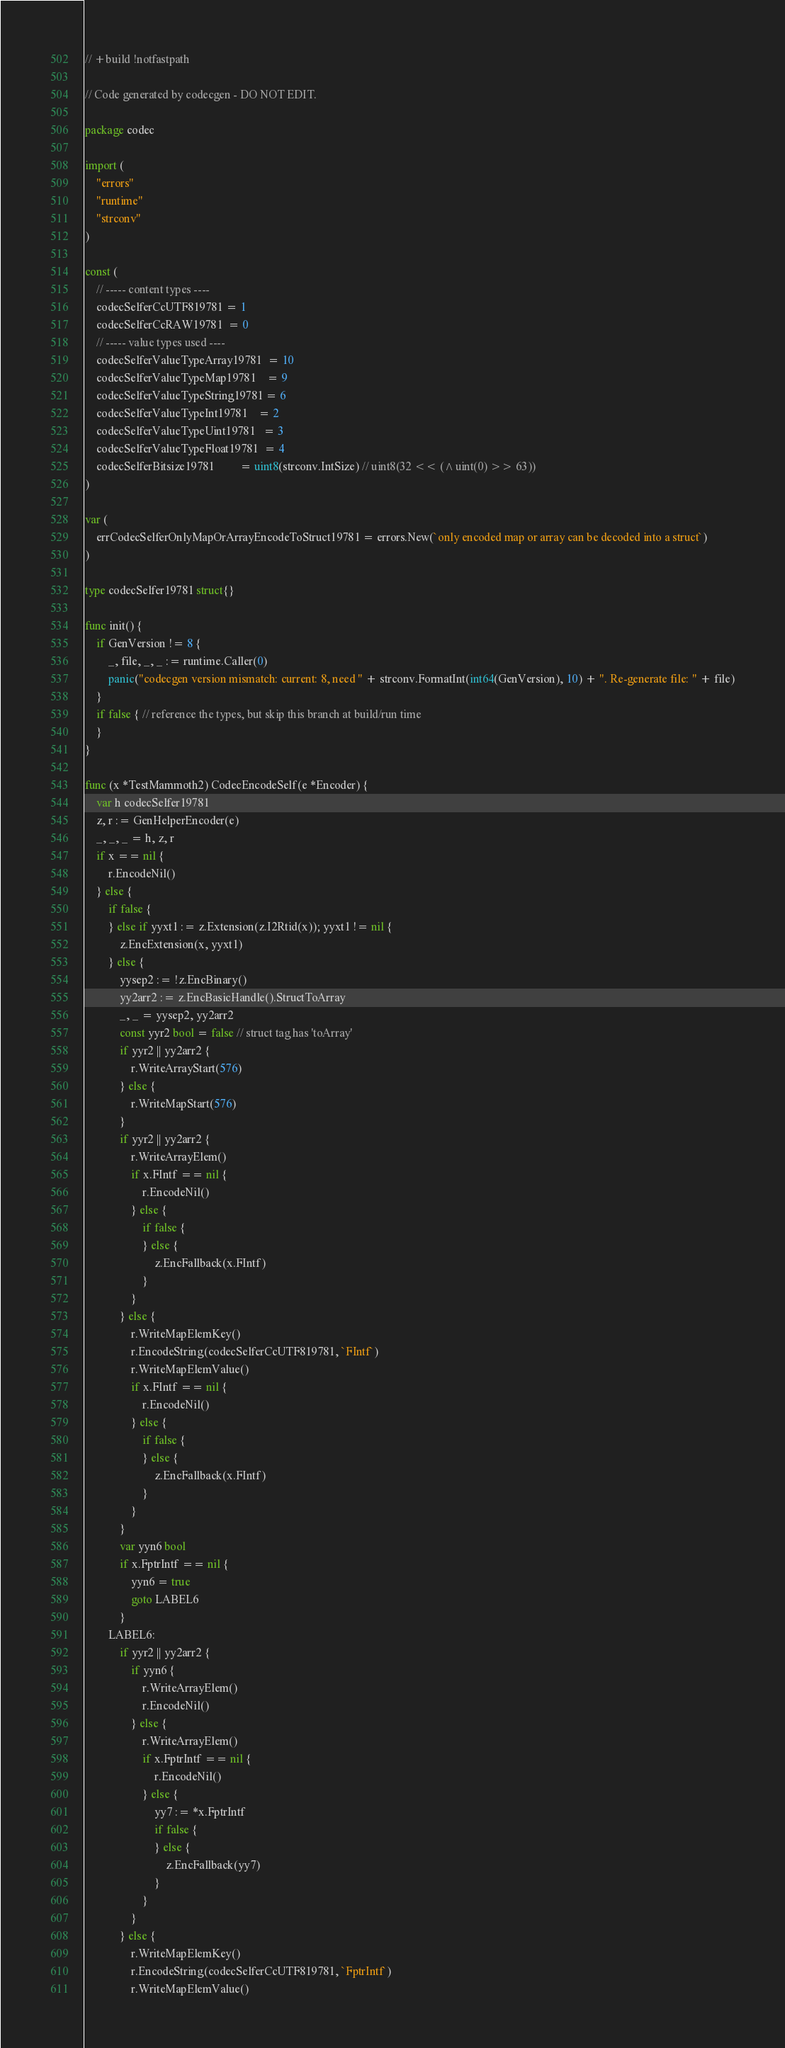Convert code to text. <code><loc_0><loc_0><loc_500><loc_500><_Go_>// +build !notfastpath

// Code generated by codecgen - DO NOT EDIT.

package codec

import (
	"errors"
	"runtime"
	"strconv"
)

const (
	// ----- content types ----
	codecSelferCcUTF819781 = 1
	codecSelferCcRAW19781  = 0
	// ----- value types used ----
	codecSelferValueTypeArray19781  = 10
	codecSelferValueTypeMap19781    = 9
	codecSelferValueTypeString19781 = 6
	codecSelferValueTypeInt19781    = 2
	codecSelferValueTypeUint19781   = 3
	codecSelferValueTypeFloat19781  = 4
	codecSelferBitsize19781         = uint8(strconv.IntSize) // uint8(32 << (^uint(0) >> 63))
)

var (
	errCodecSelferOnlyMapOrArrayEncodeToStruct19781 = errors.New(`only encoded map or array can be decoded into a struct`)
)

type codecSelfer19781 struct{}

func init() {
	if GenVersion != 8 {
		_, file, _, _ := runtime.Caller(0)
		panic("codecgen version mismatch: current: 8, need " + strconv.FormatInt(int64(GenVersion), 10) + ". Re-generate file: " + file)
	}
	if false { // reference the types, but skip this branch at build/run time
	}
}

func (x *TestMammoth2) CodecEncodeSelf(e *Encoder) {
	var h codecSelfer19781
	z, r := GenHelperEncoder(e)
	_, _, _ = h, z, r
	if x == nil {
		r.EncodeNil()
	} else {
		if false {
		} else if yyxt1 := z.Extension(z.I2Rtid(x)); yyxt1 != nil {
			z.EncExtension(x, yyxt1)
		} else {
			yysep2 := !z.EncBinary()
			yy2arr2 := z.EncBasicHandle().StructToArray
			_, _ = yysep2, yy2arr2
			const yyr2 bool = false // struct tag has 'toArray'
			if yyr2 || yy2arr2 {
				r.WriteArrayStart(576)
			} else {
				r.WriteMapStart(576)
			}
			if yyr2 || yy2arr2 {
				r.WriteArrayElem()
				if x.FIntf == nil {
					r.EncodeNil()
				} else {
					if false {
					} else {
						z.EncFallback(x.FIntf)
					}
				}
			} else {
				r.WriteMapElemKey()
				r.EncodeString(codecSelferCcUTF819781, `FIntf`)
				r.WriteMapElemValue()
				if x.FIntf == nil {
					r.EncodeNil()
				} else {
					if false {
					} else {
						z.EncFallback(x.FIntf)
					}
				}
			}
			var yyn6 bool
			if x.FptrIntf == nil {
				yyn6 = true
				goto LABEL6
			}
		LABEL6:
			if yyr2 || yy2arr2 {
				if yyn6 {
					r.WriteArrayElem()
					r.EncodeNil()
				} else {
					r.WriteArrayElem()
					if x.FptrIntf == nil {
						r.EncodeNil()
					} else {
						yy7 := *x.FptrIntf
						if false {
						} else {
							z.EncFallback(yy7)
						}
					}
				}
			} else {
				r.WriteMapElemKey()
				r.EncodeString(codecSelferCcUTF819781, `FptrIntf`)
				r.WriteMapElemValue()</code> 